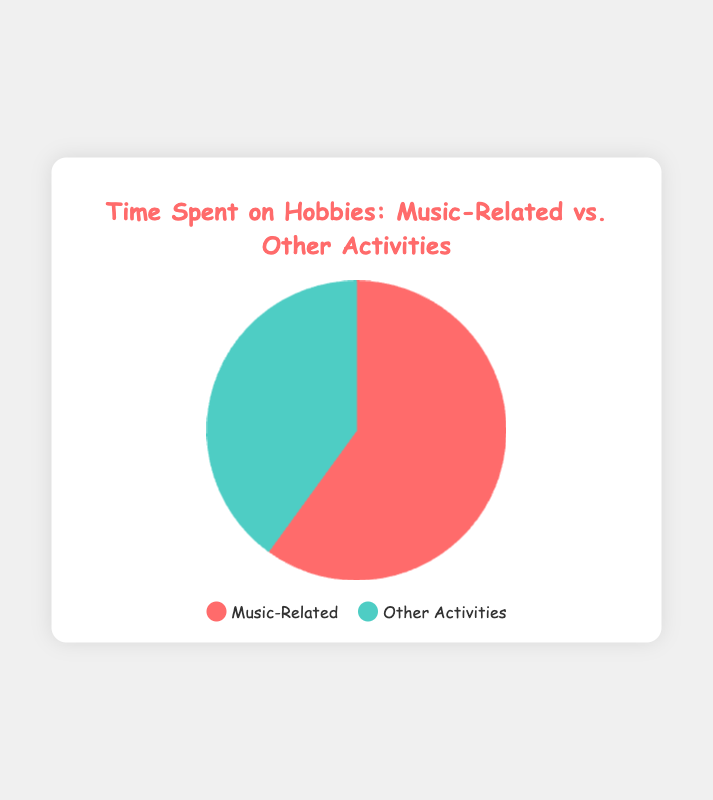what percentage of time is spent on music-related activities? The pie chart shows that music-related activities take 180 minutes out of a total of 300 minutes. The total time spent on hobbies is 180 + 120 = 300 minutes. Therefore, the percentage is (180 / 300) * 100 = 60%.
Answer: 60% how many more minutes are spent on music-related activities compared to other activities? According to the pie chart, 180 minutes are spent on music-related activities and 120 minutes on other activities. The difference is 180 - 120 = 60 minutes.
Answer: 60 minutes what is the ratio of time spent on music-related activities to other activities? The time spent on music-related activities is 180 minutes, and on other activities is 120 minutes. The ratio is 180:120, which simplifies to 3:2.
Answer: 3:2 which hobby category has the greater percentage of time spent? Looking at the pie chart, the larger section represents music-related activities. Therefore, music-related activities have the greater percentage.
Answer: music-related activities if 30 more minutes were added to other activities, which hobby category would have more total time spent? Currently, 180 minutes are spent on music-related activities and 120 minutes on other activities. Adding 30 more minutes to other activities gives 120 + 30 = 150 minutes. Since 180 (music-related) > 150 (other activities), music-related activities would still have more time spent.
Answer: music-related activities what color represents music-related activities on the pie chart? The pie chart indicates that music-related activities are represented by the reddish color section.
Answer: reddish color what is the total time spent on all hobbies? The pie chart shows 180 minutes for music-related activities and 120 minutes for other activities. Therefore, the total time spent is 180 + 120 = 300 minutes.
Answer: 300 minutes which section of the pie chart is smaller, and how much time does it represent? The pie chart shows that the smaller section represents other activities, which amounts to 120 minutes.
Answer: other activities, 120 minutes if 50 more minutes were added to music-related activities, would it represent more than 70% of the total time? Currently, music-related activities take 180 minutes out of 300. Adding 50 minutes makes it 230 minutes. The new total time would be 230 + 120 = 350 minutes. The new percentage is (230 / 350) * 100 ≈ 65.7%, which is less than 70%.
Answer: no which hobby category would you suggest cutting time from to balance the two activities equally? To balance the two activities equally, the aimed balance is 150 minutes for each. From 180 (music-related), one should cut 180 - 150 = 30 minutes.
Answer: music-related activities 